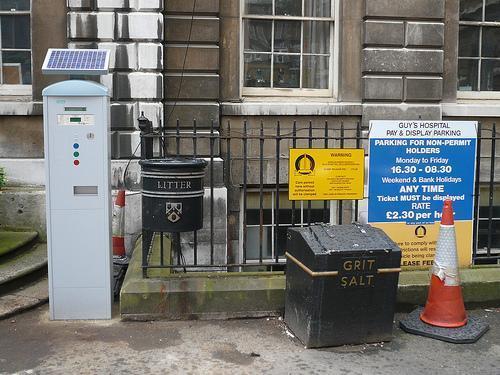How many signs are there in the picture?
Give a very brief answer. 2. 